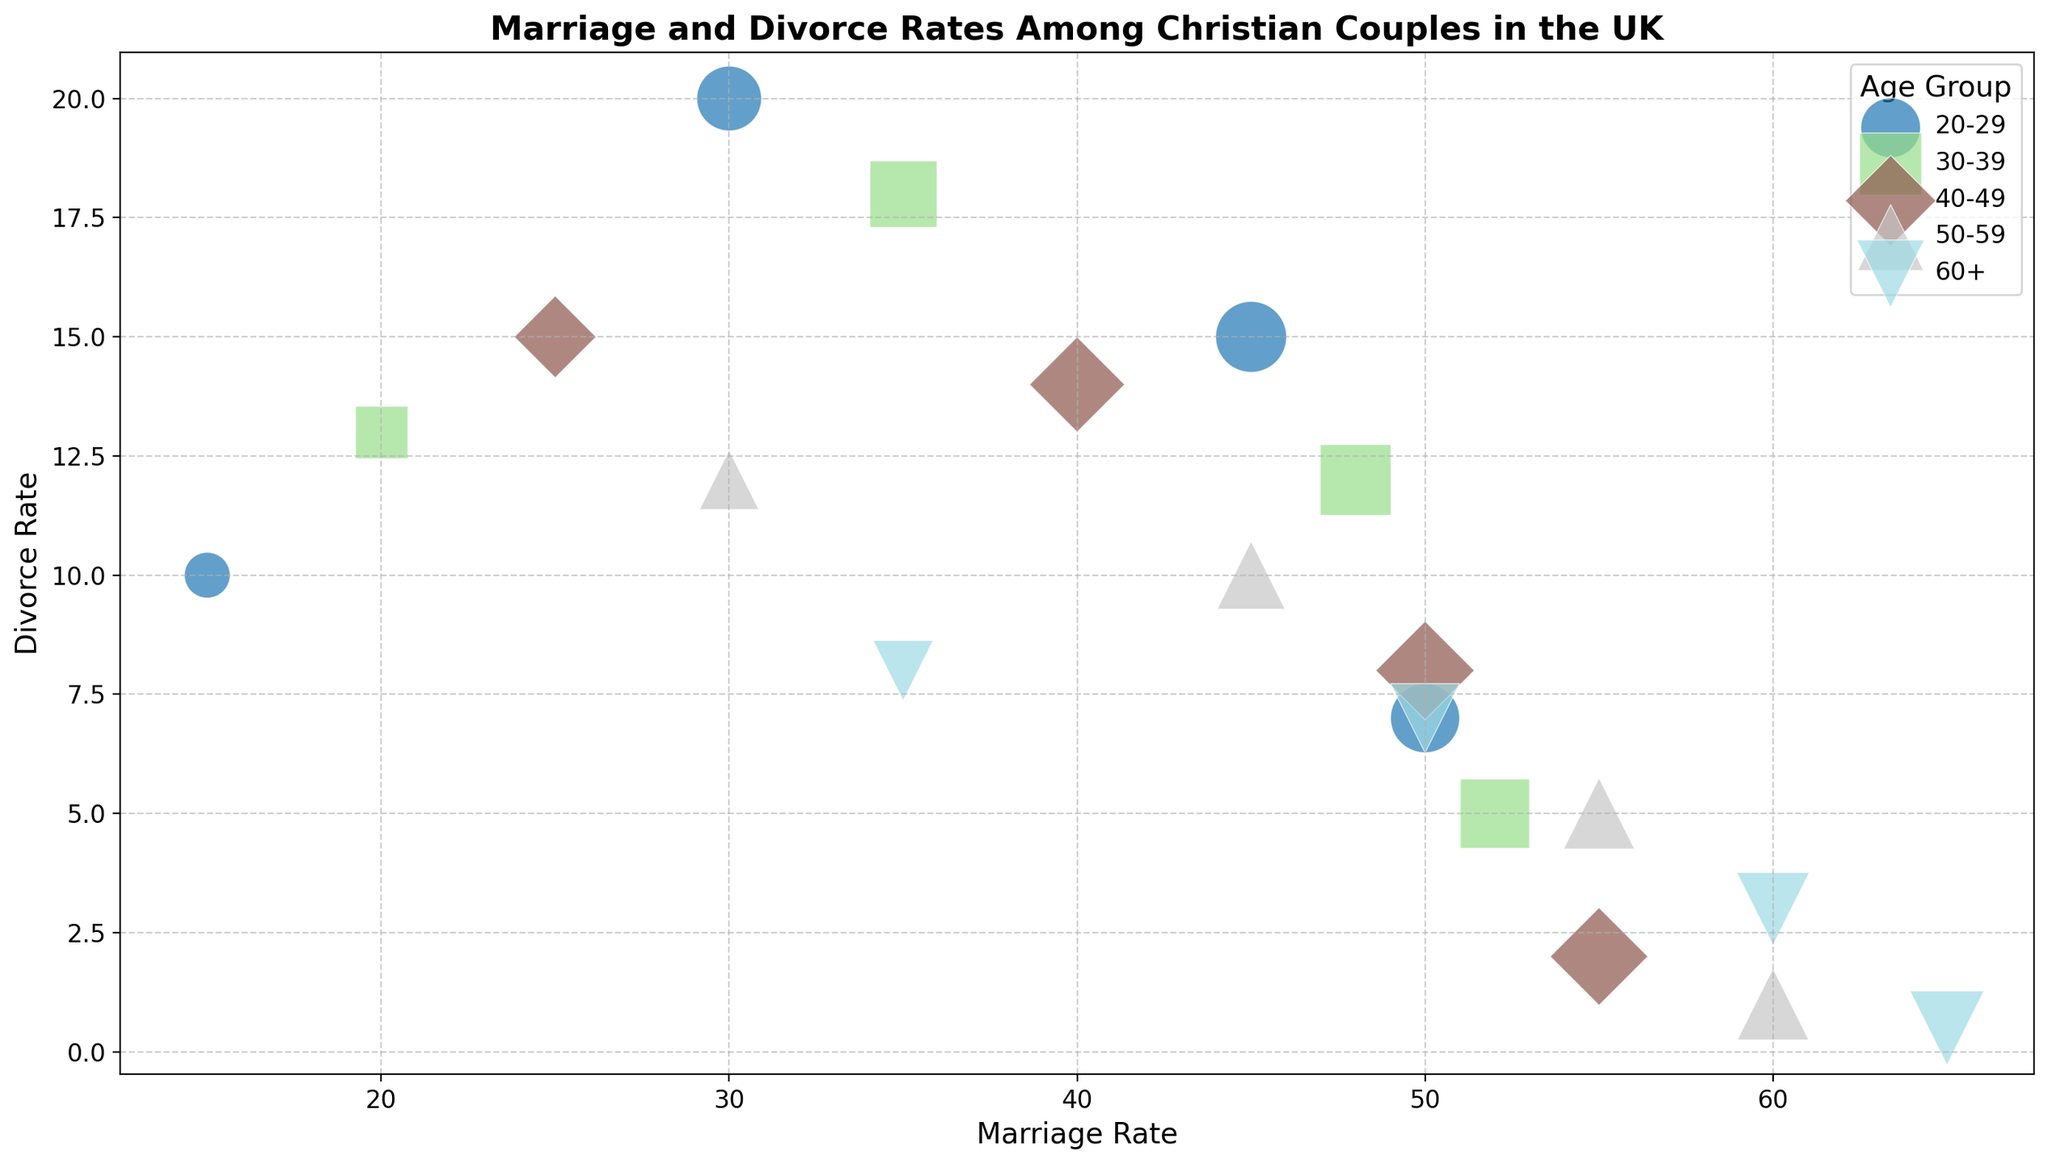What's the marriage rate for the 40-49 age group with a marriage length of 0-5 years? Look at the bubble representing the 40-49 age group with a 0-5 year marriage length and find the x-value (marriage rate) it corresponds to.
Answer: 55 Which age group has the highest divorce rate for marriages lasting 11-15 years? Locate the bubbles for each age group corresponding to the 11-15 years length of marriage and compare their y-values (divorce rates). The age group with the highest y-value has the highest divorce rate.
Answer: 20-29 Which age group has the largest bubble size in the chart? Compare the bubble sizes visually across all age groups; the largest bubble corresponds to the highest combined rate of marriage and divorce.
Answer: 60+ What is the difference in divorce rates between the age group 20-29 and 50-59 for marriages lasting 0-5 years? Identify the divorce rates of the 20-29 and 50-59 age groups for 0-5 year marriages, then calculate the difference by subtracting the smaller value from the larger value.
Answer: 6 What is the average marriage rate for the age group 30-39 across all lengths of marriage? Identify the marriage rates for the 30-39 age group across all marriage lengths, sum them up, then divide by the number of data points (4) to get the average.
Answer: 38.75 In which age group does the marriage rate decrease most sharply as the length of marriage increases from 0-5 years to 11-15 years? For each age group, subtract the marriage rate at 11-15 years from the marriage rate at 0-5 years, and find the age group with the largest difference.
Answer: 20-29 Are there any age groups where the divorce rate decreases as the length of marriage increases? Examine each age group's series of bubbles in terms of y-value (divorce rate) as the length of marriage increases and check for any decreases.
Answer: No Which age group and length of marriage combination has the lowest marriage rate? Identify the bubble with the smallest x-value (marriage rate) among all age groups and lengths of marriage.
Answer: 20-29, 16-20 years 